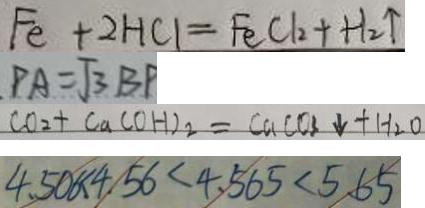Convert formula to latex. <formula><loc_0><loc_0><loc_500><loc_500>F e + 2 H C l = F e C l _ { 2 } + H _ { 2 } \uparrow 
 P A = \sqrt { 3 } B P 
 C O _ { 2 } + C a ( O H ) _ { 2 } = C a C O _ { 3 } \downarrow + H _ { 2 } O 
 4 . 5 0 6 < 4 . 5 6 < 4 . 5 6 5 < 5 . 6 5</formula> 